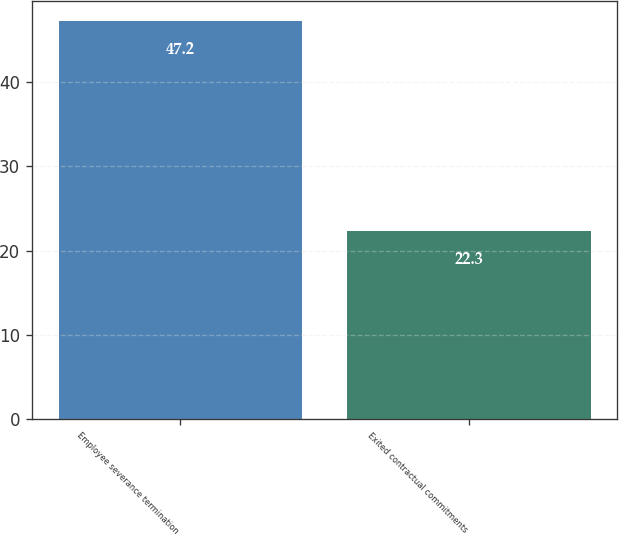Convert chart to OTSL. <chart><loc_0><loc_0><loc_500><loc_500><bar_chart><fcel>Employee severance termination<fcel>Exited contractual commitments<nl><fcel>47.2<fcel>22.3<nl></chart> 